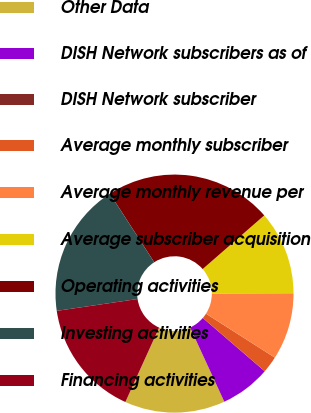<chart> <loc_0><loc_0><loc_500><loc_500><pie_chart><fcel>Other Data<fcel>DISH Network subscribers as of<fcel>DISH Network subscriber<fcel>Average monthly subscriber<fcel>Average monthly revenue per<fcel>Average subscriber acquisition<fcel>Operating activities<fcel>Investing activities<fcel>Financing activities<nl><fcel>13.64%<fcel>6.82%<fcel>0.0%<fcel>2.27%<fcel>9.09%<fcel>11.36%<fcel>22.73%<fcel>18.18%<fcel>15.91%<nl></chart> 